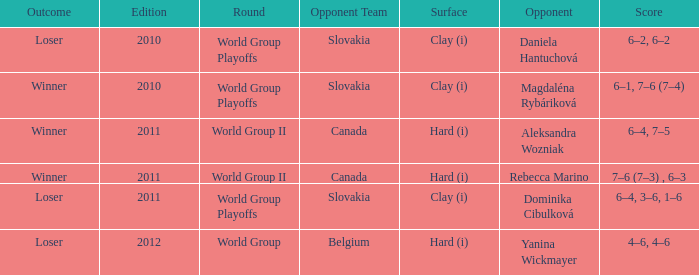What was the result when the adversary was dominika cibulková? 6–4, 3–6, 1–6. 